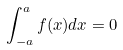Convert formula to latex. <formula><loc_0><loc_0><loc_500><loc_500>\int _ { - a } ^ { a } f ( x ) d x = 0</formula> 